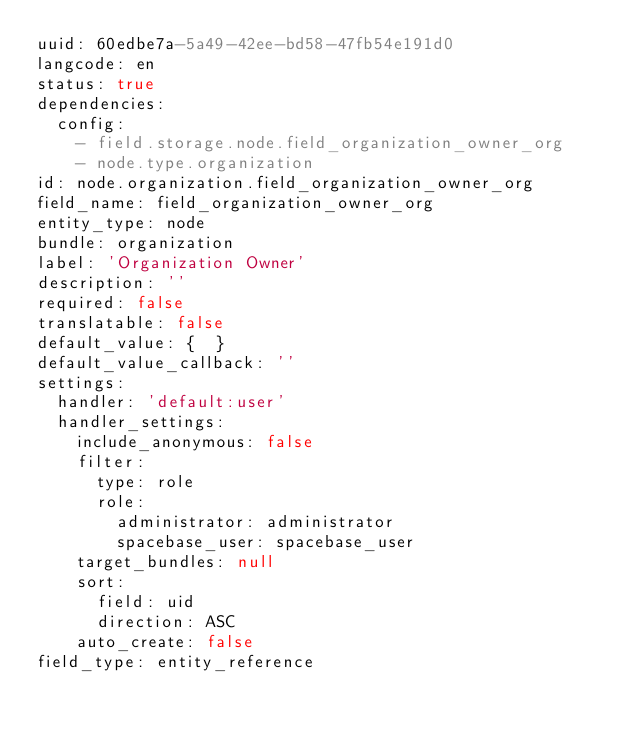Convert code to text. <code><loc_0><loc_0><loc_500><loc_500><_YAML_>uuid: 60edbe7a-5a49-42ee-bd58-47fb54e191d0
langcode: en
status: true
dependencies:
  config:
    - field.storage.node.field_organization_owner_org
    - node.type.organization
id: node.organization.field_organization_owner_org
field_name: field_organization_owner_org
entity_type: node
bundle: organization
label: 'Organization Owner'
description: ''
required: false
translatable: false
default_value: {  }
default_value_callback: ''
settings:
  handler: 'default:user'
  handler_settings:
    include_anonymous: false
    filter:
      type: role
      role:
        administrator: administrator
        spacebase_user: spacebase_user
    target_bundles: null
    sort:
      field: uid
      direction: ASC
    auto_create: false
field_type: entity_reference
</code> 